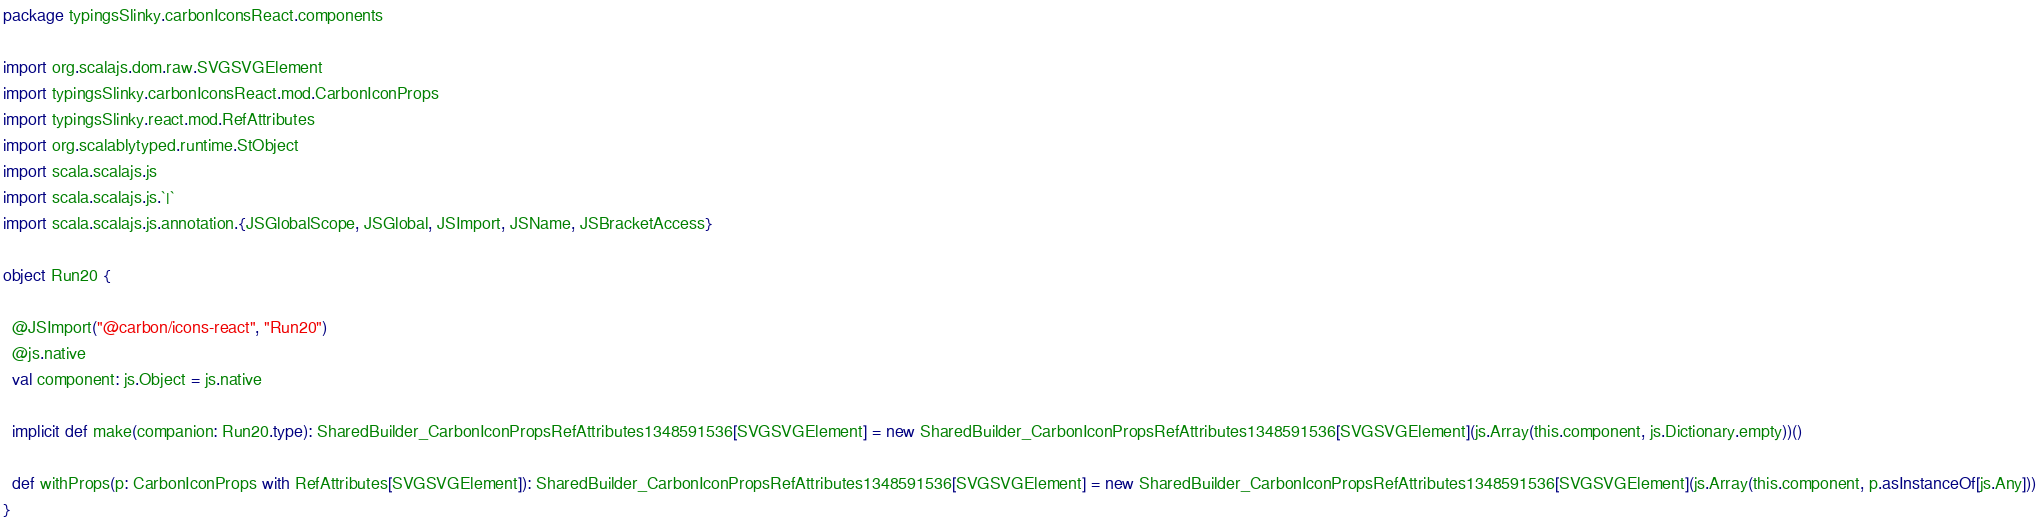Convert code to text. <code><loc_0><loc_0><loc_500><loc_500><_Scala_>package typingsSlinky.carbonIconsReact.components

import org.scalajs.dom.raw.SVGSVGElement
import typingsSlinky.carbonIconsReact.mod.CarbonIconProps
import typingsSlinky.react.mod.RefAttributes
import org.scalablytyped.runtime.StObject
import scala.scalajs.js
import scala.scalajs.js.`|`
import scala.scalajs.js.annotation.{JSGlobalScope, JSGlobal, JSImport, JSName, JSBracketAccess}

object Run20 {
  
  @JSImport("@carbon/icons-react", "Run20")
  @js.native
  val component: js.Object = js.native
  
  implicit def make(companion: Run20.type): SharedBuilder_CarbonIconPropsRefAttributes1348591536[SVGSVGElement] = new SharedBuilder_CarbonIconPropsRefAttributes1348591536[SVGSVGElement](js.Array(this.component, js.Dictionary.empty))()
  
  def withProps(p: CarbonIconProps with RefAttributes[SVGSVGElement]): SharedBuilder_CarbonIconPropsRefAttributes1348591536[SVGSVGElement] = new SharedBuilder_CarbonIconPropsRefAttributes1348591536[SVGSVGElement](js.Array(this.component, p.asInstanceOf[js.Any]))
}
</code> 